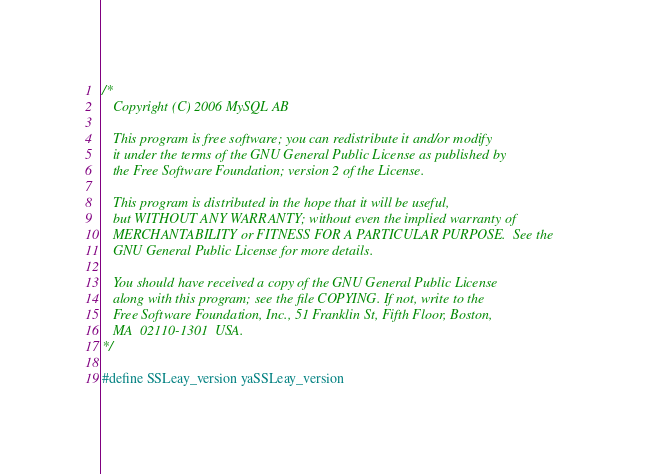Convert code to text. <code><loc_0><loc_0><loc_500><loc_500><_C_>/*
   Copyright (C) 2006 MySQL AB

   This program is free software; you can redistribute it and/or modify
   it under the terms of the GNU General Public License as published by
   the Free Software Foundation; version 2 of the License.

   This program is distributed in the hope that it will be useful,
   but WITHOUT ANY WARRANTY; without even the implied warranty of
   MERCHANTABILITY or FITNESS FOR A PARTICULAR PURPOSE.  See the
   GNU General Public License for more details.

   You should have received a copy of the GNU General Public License
   along with this program; see the file COPYING. If not, write to the
   Free Software Foundation, Inc., 51 Franklin St, Fifth Floor, Boston,
   MA  02110-1301  USA.
*/

#define SSLeay_version yaSSLeay_version
</code> 